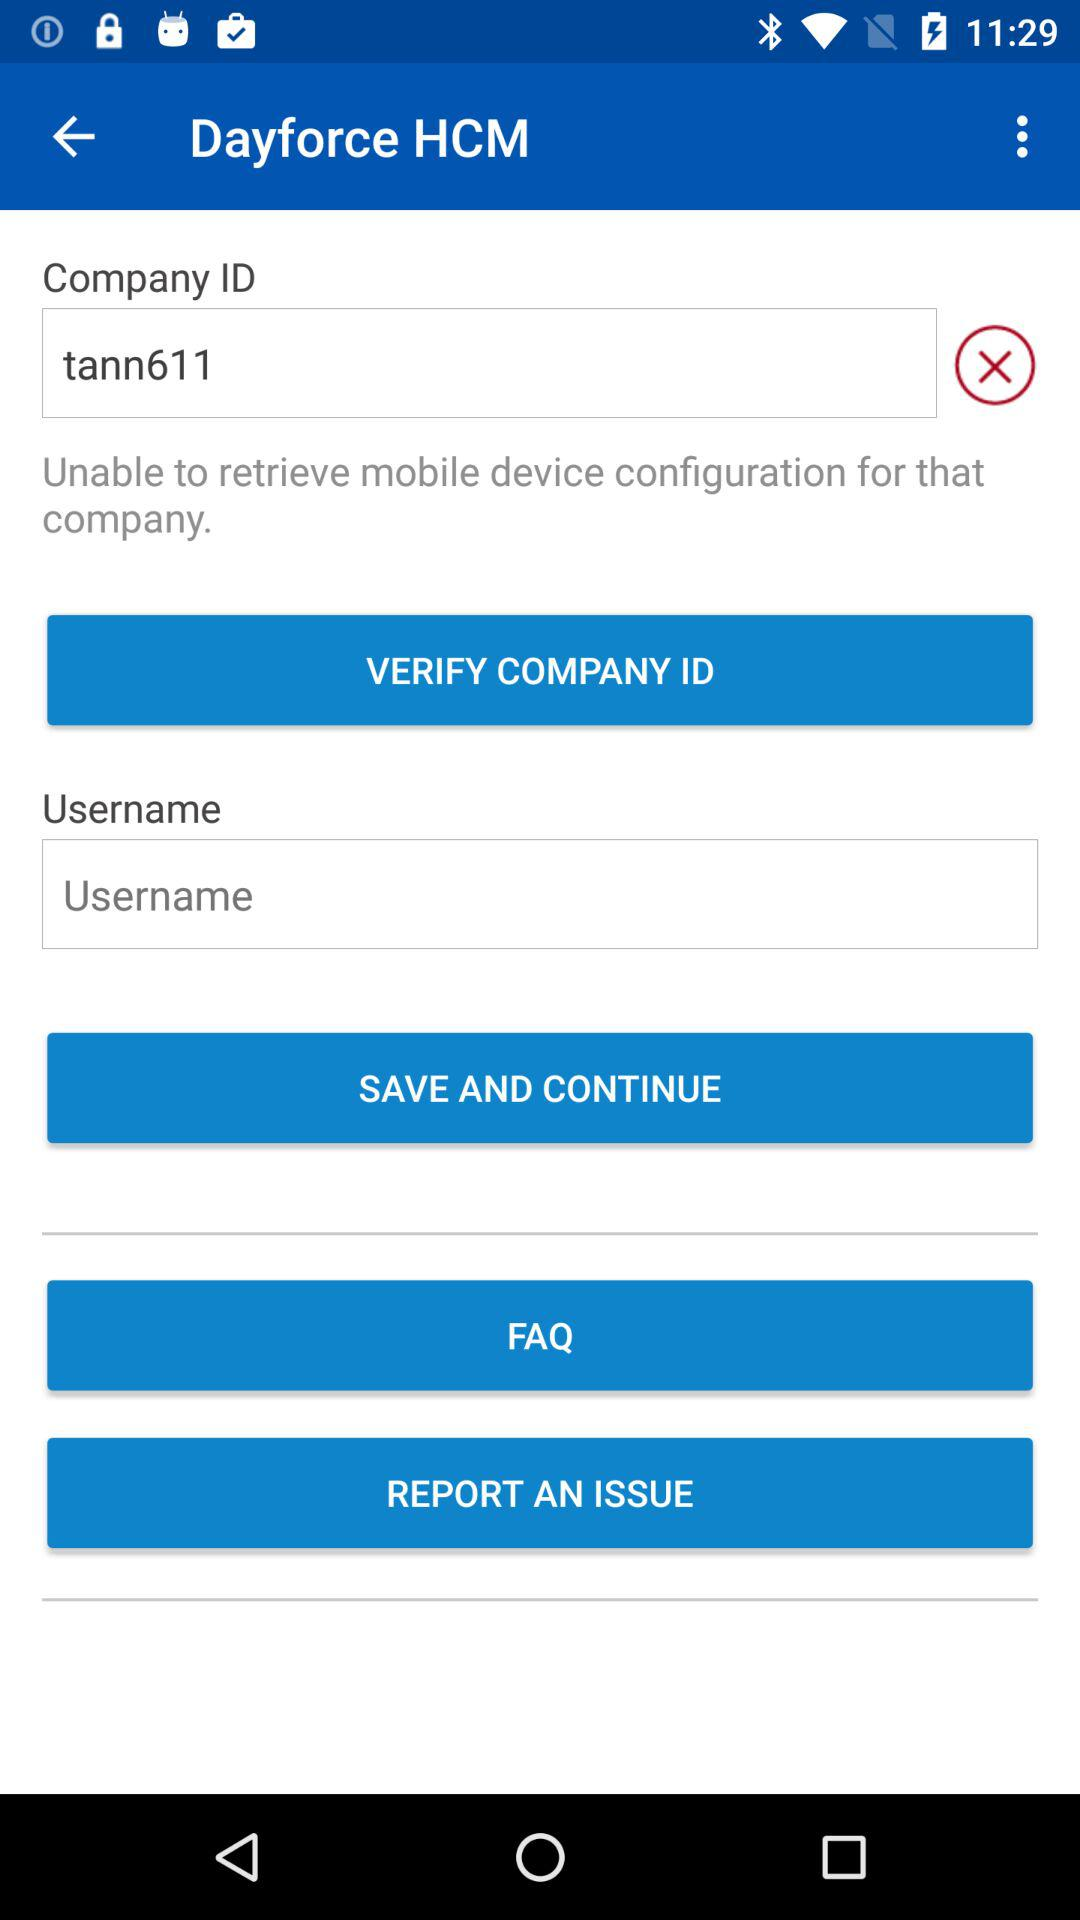What is the name of the application? The name of the application is "Dayforce HCM". 